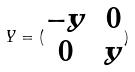<formula> <loc_0><loc_0><loc_500><loc_500>Y = ( \begin{matrix} - y & 0 \\ 0 & y \end{matrix} )</formula> 